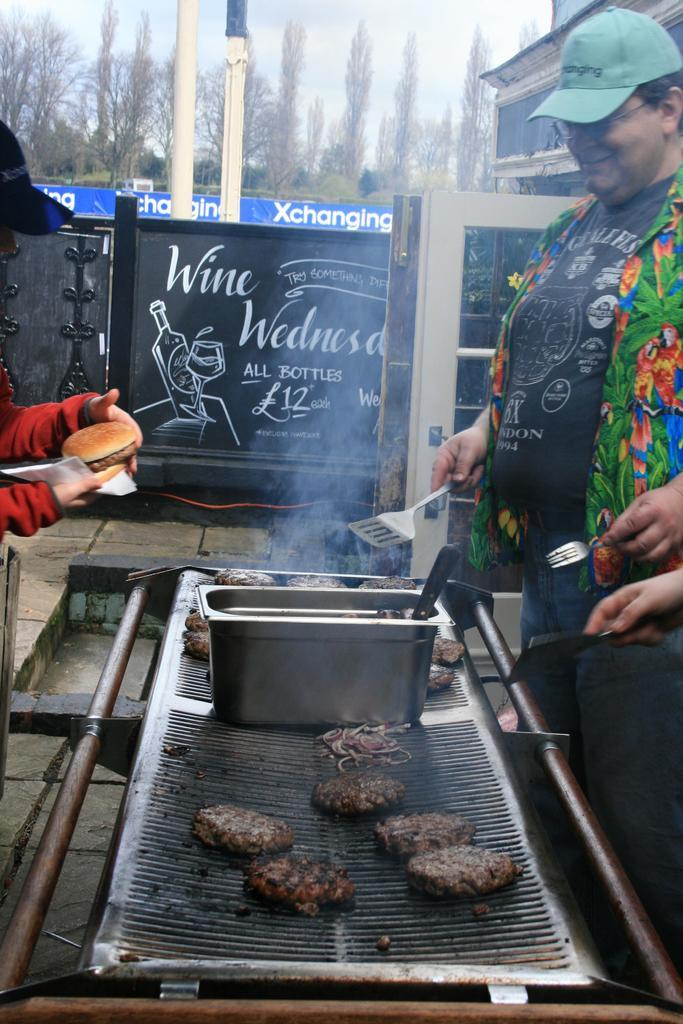Provide a one-sentence caption for the provided image. men are cooking burger patties on a smoking grill next to a sign that says "wine wednesday.". 